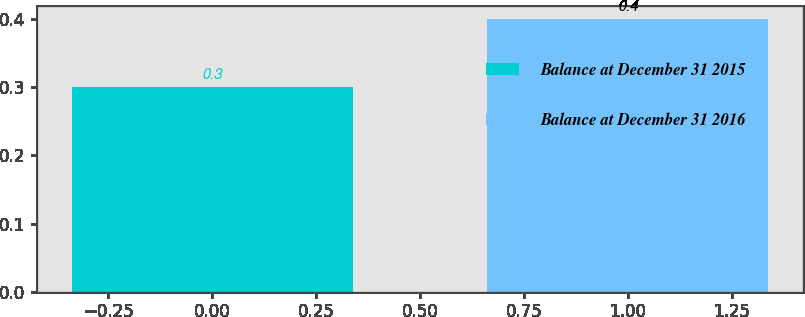Convert chart to OTSL. <chart><loc_0><loc_0><loc_500><loc_500><bar_chart><fcel>Balance at December 31 2015<fcel>Balance at December 31 2016<nl><fcel>0.3<fcel>0.4<nl></chart> 